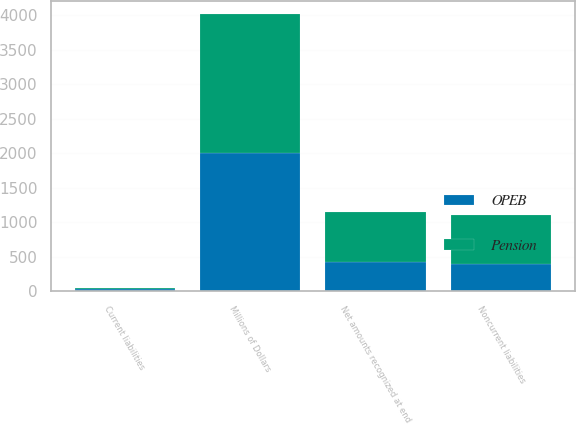<chart> <loc_0><loc_0><loc_500><loc_500><stacked_bar_chart><ecel><fcel>Millions of Dollars<fcel>Current liabilities<fcel>Noncurrent liabilities<fcel>Net amounts recognized at end<nl><fcel>Pension<fcel>2008<fcel>12<fcel>717<fcel>729<nl><fcel>OPEB<fcel>2008<fcel>30<fcel>388<fcel>418<nl></chart> 